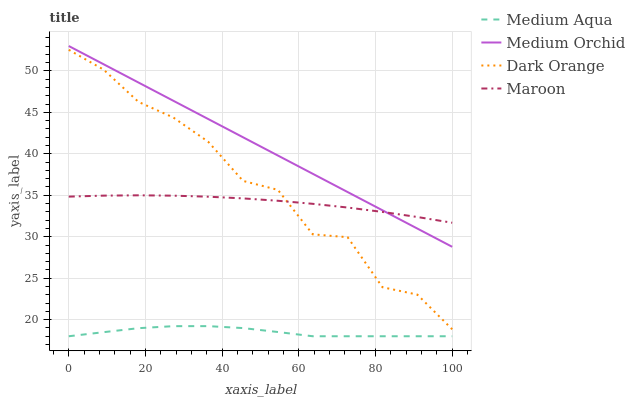Does Medium Orchid have the minimum area under the curve?
Answer yes or no. No. Does Medium Aqua have the maximum area under the curve?
Answer yes or no. No. Is Medium Aqua the smoothest?
Answer yes or no. No. Is Medium Aqua the roughest?
Answer yes or no. No. Does Medium Orchid have the lowest value?
Answer yes or no. No. Does Medium Aqua have the highest value?
Answer yes or no. No. Is Dark Orange less than Medium Orchid?
Answer yes or no. Yes. Is Dark Orange greater than Medium Aqua?
Answer yes or no. Yes. Does Dark Orange intersect Medium Orchid?
Answer yes or no. No. 